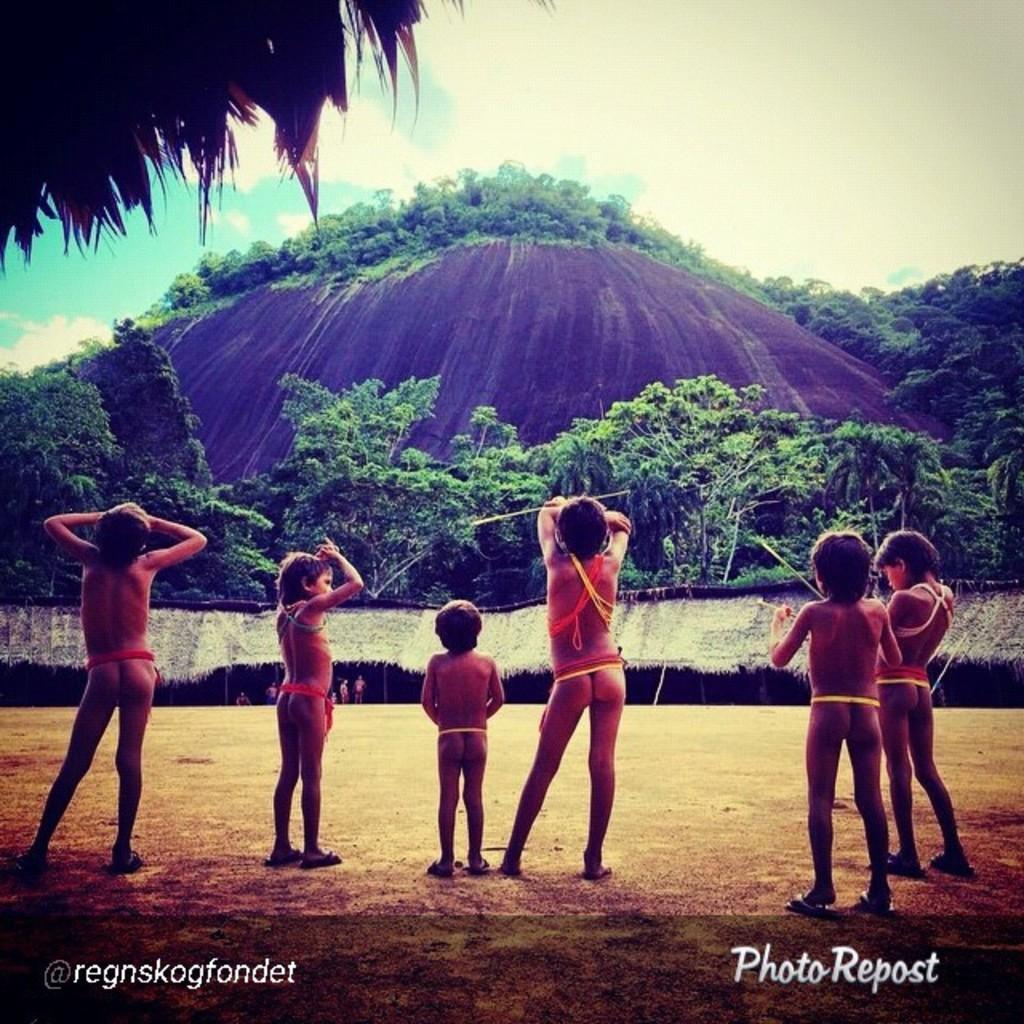Describe this image in one or two sentences. In the picture we can see some children are standing on the mud surface without clothes and behind them, we can see the huts and behind it, we can see trees and rock hill and on the top of it also we can see trees and in the background we can see a sky with clouds. 